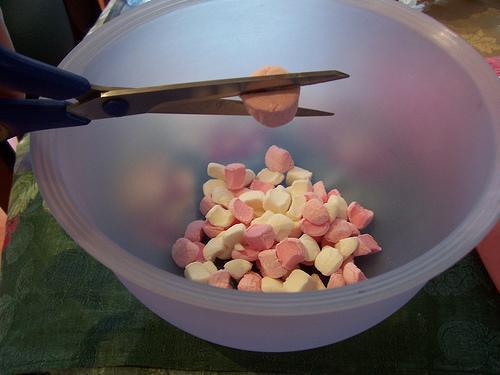How many people are standing up?
Give a very brief answer. 0. 